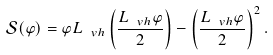Convert formula to latex. <formula><loc_0><loc_0><loc_500><loc_500>\mathcal { S } ( \varphi ) = \varphi L _ { \ v h } \left ( \frac { L _ { \ v h } \varphi } { 2 } \right ) - \left ( \frac { L _ { \ v h } \varphi } { 2 } \right ) ^ { 2 } .</formula> 